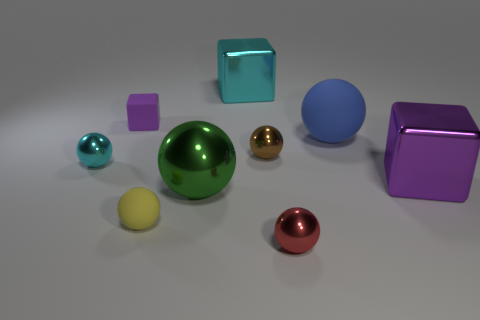The cyan thing that is in front of the large shiny object behind the small cyan ball is what shape?
Give a very brief answer. Sphere. Are any tiny balls visible?
Provide a succinct answer. Yes. There is a matte object in front of the big matte sphere; what color is it?
Ensure brevity in your answer.  Yellow. There is a large object that is the same color as the rubber block; what material is it?
Your answer should be compact. Metal. Are there any shiny balls to the left of the big cyan thing?
Ensure brevity in your answer.  Yes. Is the number of large purple metal cubes greater than the number of small metallic spheres?
Ensure brevity in your answer.  No. The big shiny cube that is in front of the large metallic block that is to the left of the metal ball in front of the yellow matte ball is what color?
Provide a succinct answer. Purple. There is a small sphere that is the same material as the tiny purple block; what color is it?
Provide a succinct answer. Yellow. What number of things are metallic spheres that are in front of the big green metal object or things in front of the tiny yellow matte object?
Your answer should be very brief. 1. There is a matte object on the right side of the large green ball; does it have the same size as the thing that is to the right of the blue sphere?
Your answer should be compact. Yes. 